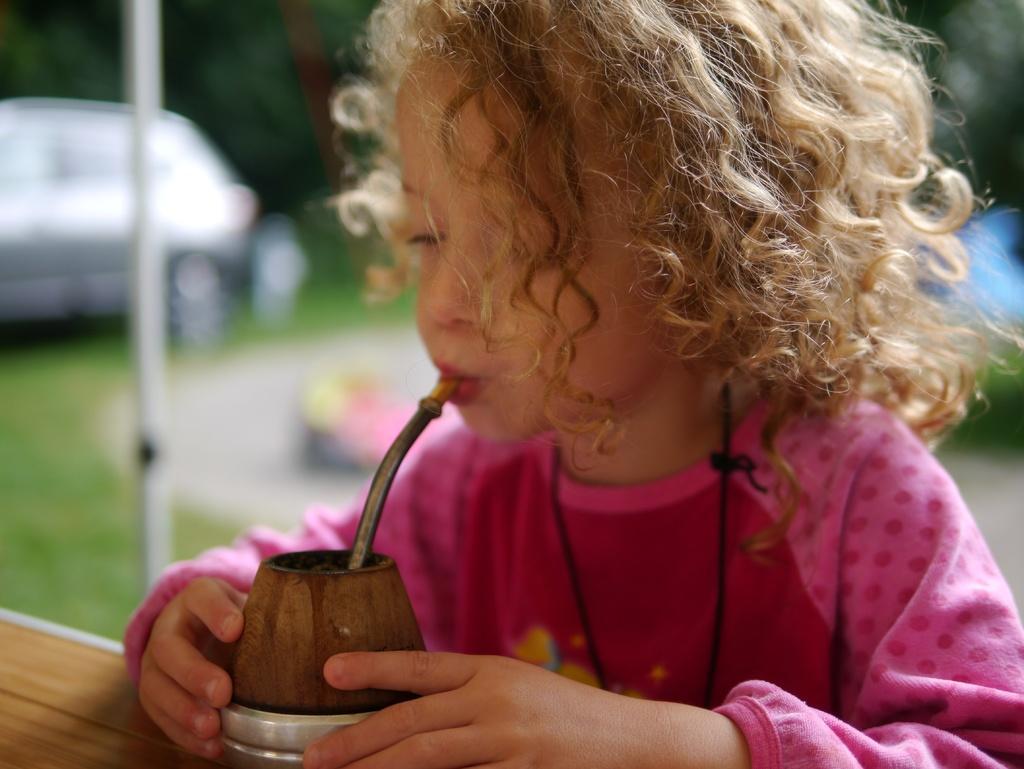Can you describe this image briefly? At the bottom of the image there is a wooden surface. On the wooden surface there is an object with pipe. Behind that there is a girl and she kept that pipe in the mouth. Behind her there is a blur image with a car and a pole. 